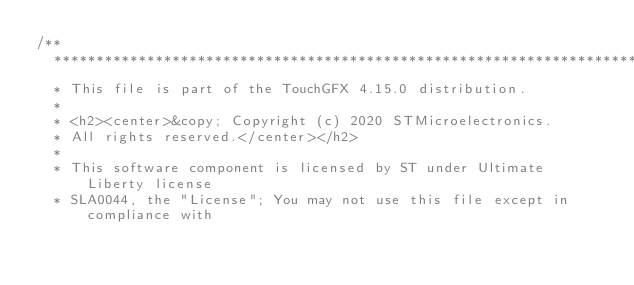<code> <loc_0><loc_0><loc_500><loc_500><_C++_>/**
  ******************************************************************************
  * This file is part of the TouchGFX 4.15.0 distribution.
  *
  * <h2><center>&copy; Copyright (c) 2020 STMicroelectronics.
  * All rights reserved.</center></h2>
  *
  * This software component is licensed by ST under Ultimate Liberty license
  * SLA0044, the "License"; You may not use this file except in compliance with</code> 